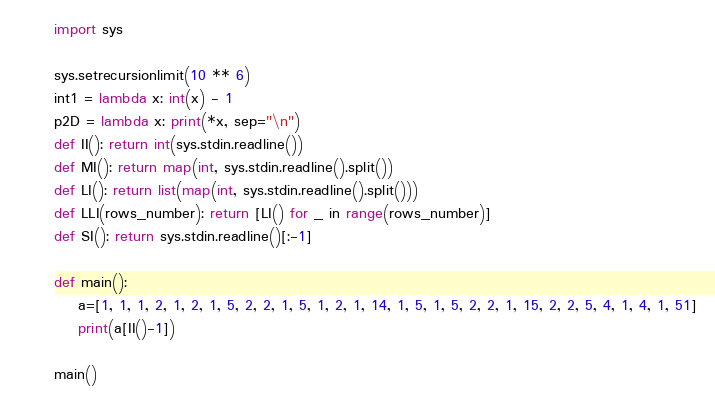<code> <loc_0><loc_0><loc_500><loc_500><_Python_>import sys

sys.setrecursionlimit(10 ** 6)
int1 = lambda x: int(x) - 1
p2D = lambda x: print(*x, sep="\n")
def II(): return int(sys.stdin.readline())
def MI(): return map(int, sys.stdin.readline().split())
def LI(): return list(map(int, sys.stdin.readline().split()))
def LLI(rows_number): return [LI() for _ in range(rows_number)]
def SI(): return sys.stdin.readline()[:-1]

def main():
    a=[1, 1, 1, 2, 1, 2, 1, 5, 2, 2, 1, 5, 1, 2, 1, 14, 1, 5, 1, 5, 2, 2, 1, 15, 2, 2, 5, 4, 1, 4, 1, 51]
    print(a[II()-1])

main()</code> 